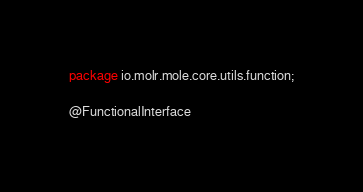<code> <loc_0><loc_0><loc_500><loc_500><_Java_>package io.molr.mole.core.utils.function;

@FunctionalInterface</code> 